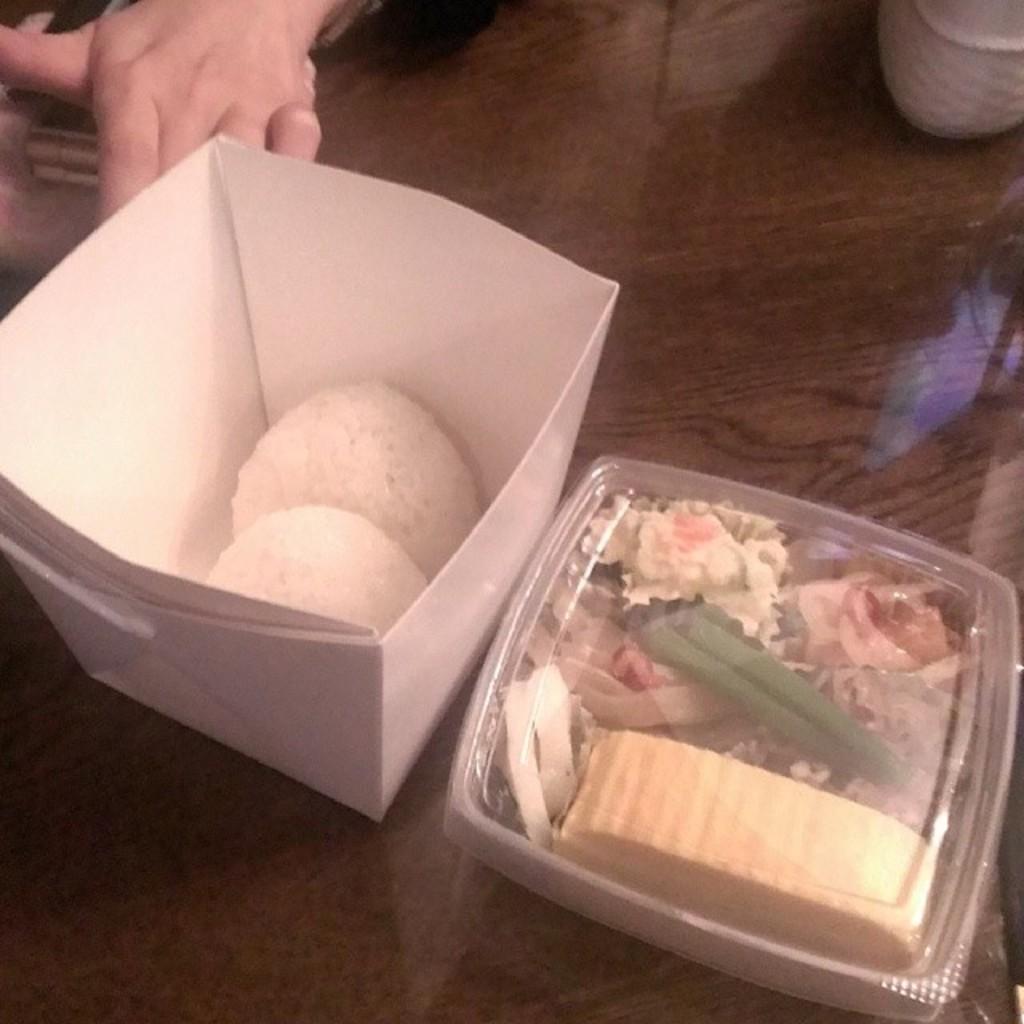How would you summarize this image in a sentence or two? In this image we can see food items in boxes on the table. To the left side of the image there is persons hand. 